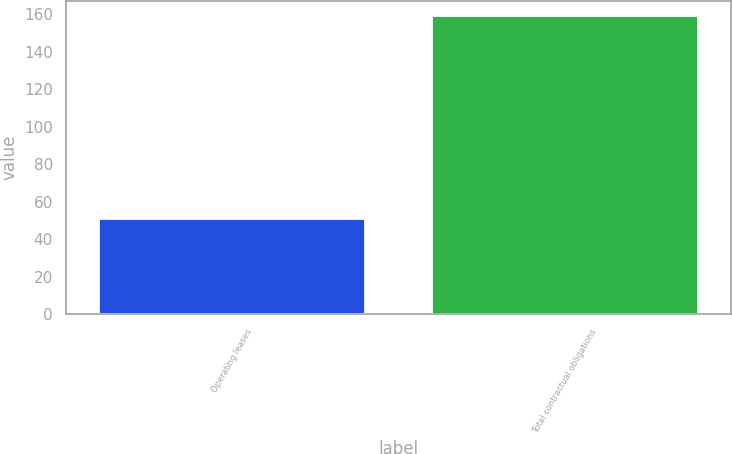<chart> <loc_0><loc_0><loc_500><loc_500><bar_chart><fcel>Operating leases<fcel>Total contractual obligations<nl><fcel>51<fcel>158.9<nl></chart> 